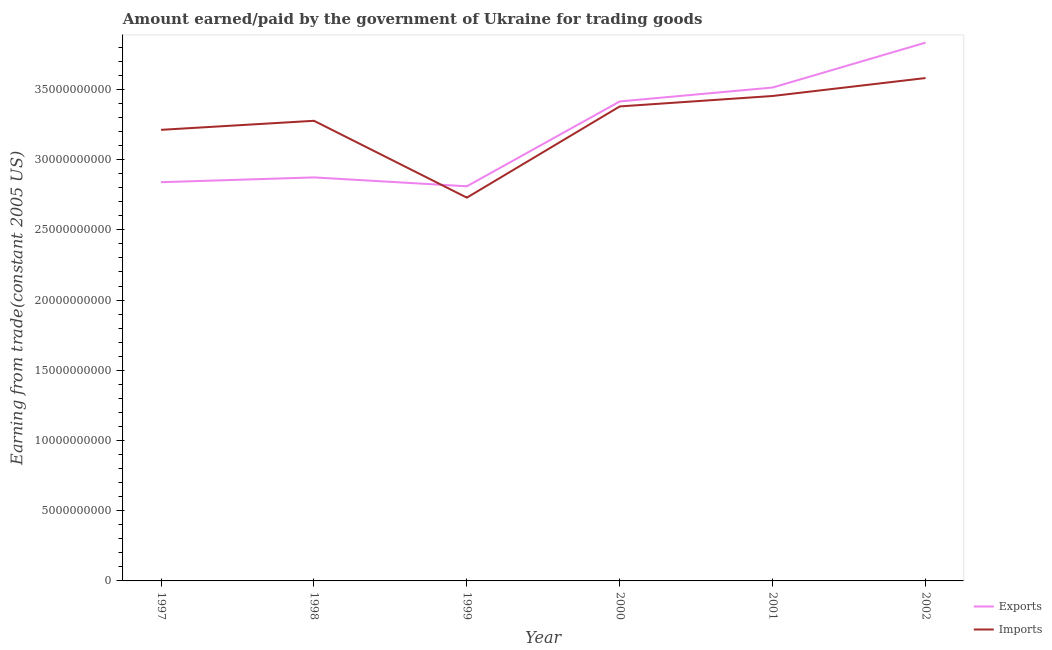How many different coloured lines are there?
Provide a short and direct response. 2. Does the line corresponding to amount paid for imports intersect with the line corresponding to amount earned from exports?
Your answer should be very brief. Yes. Is the number of lines equal to the number of legend labels?
Your answer should be compact. Yes. What is the amount earned from exports in 2001?
Offer a terse response. 3.51e+1. Across all years, what is the maximum amount paid for imports?
Provide a short and direct response. 3.58e+1. Across all years, what is the minimum amount earned from exports?
Your answer should be compact. 2.81e+1. In which year was the amount paid for imports maximum?
Give a very brief answer. 2002. In which year was the amount paid for imports minimum?
Your answer should be very brief. 1999. What is the total amount paid for imports in the graph?
Provide a succinct answer. 1.96e+11. What is the difference between the amount earned from exports in 1998 and that in 2000?
Provide a short and direct response. -5.41e+09. What is the difference between the amount earned from exports in 1999 and the amount paid for imports in 2002?
Your response must be concise. -7.71e+09. What is the average amount paid for imports per year?
Ensure brevity in your answer.  3.27e+1. In the year 1999, what is the difference between the amount earned from exports and amount paid for imports?
Offer a very short reply. 8.09e+08. In how many years, is the amount paid for imports greater than 31000000000 US$?
Keep it short and to the point. 5. What is the ratio of the amount earned from exports in 1998 to that in 2001?
Give a very brief answer. 0.82. Is the amount paid for imports in 2001 less than that in 2002?
Ensure brevity in your answer.  Yes. Is the difference between the amount paid for imports in 1997 and 1999 greater than the difference between the amount earned from exports in 1997 and 1999?
Provide a succinct answer. Yes. What is the difference between the highest and the second highest amount earned from exports?
Offer a terse response. 3.20e+09. What is the difference between the highest and the lowest amount earned from exports?
Keep it short and to the point. 1.02e+1. In how many years, is the amount earned from exports greater than the average amount earned from exports taken over all years?
Provide a succinct answer. 3. Does the amount paid for imports monotonically increase over the years?
Your answer should be compact. No. How many lines are there?
Provide a short and direct response. 2. How many legend labels are there?
Make the answer very short. 2. What is the title of the graph?
Provide a short and direct response. Amount earned/paid by the government of Ukraine for trading goods. What is the label or title of the Y-axis?
Ensure brevity in your answer.  Earning from trade(constant 2005 US). What is the Earning from trade(constant 2005 US) of Exports in 1997?
Offer a very short reply. 2.84e+1. What is the Earning from trade(constant 2005 US) of Imports in 1997?
Your answer should be compact. 3.21e+1. What is the Earning from trade(constant 2005 US) of Exports in 1998?
Give a very brief answer. 2.87e+1. What is the Earning from trade(constant 2005 US) in Imports in 1998?
Make the answer very short. 3.28e+1. What is the Earning from trade(constant 2005 US) in Exports in 1999?
Offer a very short reply. 2.81e+1. What is the Earning from trade(constant 2005 US) in Imports in 1999?
Keep it short and to the point. 2.73e+1. What is the Earning from trade(constant 2005 US) of Exports in 2000?
Offer a very short reply. 3.41e+1. What is the Earning from trade(constant 2005 US) of Imports in 2000?
Your answer should be very brief. 3.38e+1. What is the Earning from trade(constant 2005 US) in Exports in 2001?
Ensure brevity in your answer.  3.51e+1. What is the Earning from trade(constant 2005 US) in Imports in 2001?
Give a very brief answer. 3.45e+1. What is the Earning from trade(constant 2005 US) in Exports in 2002?
Provide a succinct answer. 3.83e+1. What is the Earning from trade(constant 2005 US) in Imports in 2002?
Offer a terse response. 3.58e+1. Across all years, what is the maximum Earning from trade(constant 2005 US) of Exports?
Make the answer very short. 3.83e+1. Across all years, what is the maximum Earning from trade(constant 2005 US) in Imports?
Provide a short and direct response. 3.58e+1. Across all years, what is the minimum Earning from trade(constant 2005 US) in Exports?
Ensure brevity in your answer.  2.81e+1. Across all years, what is the minimum Earning from trade(constant 2005 US) of Imports?
Your response must be concise. 2.73e+1. What is the total Earning from trade(constant 2005 US) of Exports in the graph?
Offer a very short reply. 1.93e+11. What is the total Earning from trade(constant 2005 US) in Imports in the graph?
Keep it short and to the point. 1.96e+11. What is the difference between the Earning from trade(constant 2005 US) in Exports in 1997 and that in 1998?
Ensure brevity in your answer.  -3.41e+08. What is the difference between the Earning from trade(constant 2005 US) in Imports in 1997 and that in 1998?
Your answer should be compact. -6.42e+08. What is the difference between the Earning from trade(constant 2005 US) of Exports in 1997 and that in 1999?
Give a very brief answer. 2.91e+08. What is the difference between the Earning from trade(constant 2005 US) of Imports in 1997 and that in 1999?
Your answer should be compact. 4.83e+09. What is the difference between the Earning from trade(constant 2005 US) of Exports in 1997 and that in 2000?
Ensure brevity in your answer.  -5.75e+09. What is the difference between the Earning from trade(constant 2005 US) of Imports in 1997 and that in 2000?
Offer a terse response. -1.67e+09. What is the difference between the Earning from trade(constant 2005 US) of Exports in 1997 and that in 2001?
Your answer should be very brief. -6.74e+09. What is the difference between the Earning from trade(constant 2005 US) of Imports in 1997 and that in 2001?
Provide a succinct answer. -2.41e+09. What is the difference between the Earning from trade(constant 2005 US) of Exports in 1997 and that in 2002?
Ensure brevity in your answer.  -9.94e+09. What is the difference between the Earning from trade(constant 2005 US) of Imports in 1997 and that in 2002?
Your answer should be compact. -3.69e+09. What is the difference between the Earning from trade(constant 2005 US) of Exports in 1998 and that in 1999?
Offer a terse response. 6.32e+08. What is the difference between the Earning from trade(constant 2005 US) of Imports in 1998 and that in 1999?
Keep it short and to the point. 5.47e+09. What is the difference between the Earning from trade(constant 2005 US) of Exports in 1998 and that in 2000?
Provide a short and direct response. -5.41e+09. What is the difference between the Earning from trade(constant 2005 US) in Imports in 1998 and that in 2000?
Your response must be concise. -1.02e+09. What is the difference between the Earning from trade(constant 2005 US) in Exports in 1998 and that in 2001?
Your answer should be very brief. -6.40e+09. What is the difference between the Earning from trade(constant 2005 US) in Imports in 1998 and that in 2001?
Your answer should be compact. -1.77e+09. What is the difference between the Earning from trade(constant 2005 US) in Exports in 1998 and that in 2002?
Give a very brief answer. -9.60e+09. What is the difference between the Earning from trade(constant 2005 US) in Imports in 1998 and that in 2002?
Keep it short and to the point. -3.05e+09. What is the difference between the Earning from trade(constant 2005 US) of Exports in 1999 and that in 2000?
Make the answer very short. -6.04e+09. What is the difference between the Earning from trade(constant 2005 US) of Imports in 1999 and that in 2000?
Offer a very short reply. -6.50e+09. What is the difference between the Earning from trade(constant 2005 US) of Exports in 1999 and that in 2001?
Keep it short and to the point. -7.03e+09. What is the difference between the Earning from trade(constant 2005 US) in Imports in 1999 and that in 2001?
Your answer should be very brief. -7.24e+09. What is the difference between the Earning from trade(constant 2005 US) in Exports in 1999 and that in 2002?
Make the answer very short. -1.02e+1. What is the difference between the Earning from trade(constant 2005 US) in Imports in 1999 and that in 2002?
Keep it short and to the point. -8.52e+09. What is the difference between the Earning from trade(constant 2005 US) in Exports in 2000 and that in 2001?
Your answer should be very brief. -9.90e+08. What is the difference between the Earning from trade(constant 2005 US) in Imports in 2000 and that in 2001?
Offer a very short reply. -7.43e+08. What is the difference between the Earning from trade(constant 2005 US) in Exports in 2000 and that in 2002?
Provide a short and direct response. -4.19e+09. What is the difference between the Earning from trade(constant 2005 US) in Imports in 2000 and that in 2002?
Your response must be concise. -2.02e+09. What is the difference between the Earning from trade(constant 2005 US) in Exports in 2001 and that in 2002?
Offer a terse response. -3.20e+09. What is the difference between the Earning from trade(constant 2005 US) of Imports in 2001 and that in 2002?
Your answer should be very brief. -1.28e+09. What is the difference between the Earning from trade(constant 2005 US) of Exports in 1997 and the Earning from trade(constant 2005 US) of Imports in 1998?
Ensure brevity in your answer.  -4.37e+09. What is the difference between the Earning from trade(constant 2005 US) in Exports in 1997 and the Earning from trade(constant 2005 US) in Imports in 1999?
Keep it short and to the point. 1.10e+09. What is the difference between the Earning from trade(constant 2005 US) of Exports in 1997 and the Earning from trade(constant 2005 US) of Imports in 2000?
Keep it short and to the point. -5.40e+09. What is the difference between the Earning from trade(constant 2005 US) of Exports in 1997 and the Earning from trade(constant 2005 US) of Imports in 2001?
Your answer should be very brief. -6.14e+09. What is the difference between the Earning from trade(constant 2005 US) in Exports in 1997 and the Earning from trade(constant 2005 US) in Imports in 2002?
Give a very brief answer. -7.42e+09. What is the difference between the Earning from trade(constant 2005 US) of Exports in 1998 and the Earning from trade(constant 2005 US) of Imports in 1999?
Give a very brief answer. 1.44e+09. What is the difference between the Earning from trade(constant 2005 US) of Exports in 1998 and the Earning from trade(constant 2005 US) of Imports in 2000?
Your answer should be compact. -5.05e+09. What is the difference between the Earning from trade(constant 2005 US) of Exports in 1998 and the Earning from trade(constant 2005 US) of Imports in 2001?
Provide a short and direct response. -5.80e+09. What is the difference between the Earning from trade(constant 2005 US) of Exports in 1998 and the Earning from trade(constant 2005 US) of Imports in 2002?
Ensure brevity in your answer.  -7.08e+09. What is the difference between the Earning from trade(constant 2005 US) of Exports in 1999 and the Earning from trade(constant 2005 US) of Imports in 2000?
Your answer should be very brief. -5.69e+09. What is the difference between the Earning from trade(constant 2005 US) of Exports in 1999 and the Earning from trade(constant 2005 US) of Imports in 2001?
Ensure brevity in your answer.  -6.43e+09. What is the difference between the Earning from trade(constant 2005 US) in Exports in 1999 and the Earning from trade(constant 2005 US) in Imports in 2002?
Keep it short and to the point. -7.71e+09. What is the difference between the Earning from trade(constant 2005 US) in Exports in 2000 and the Earning from trade(constant 2005 US) in Imports in 2001?
Your response must be concise. -3.88e+08. What is the difference between the Earning from trade(constant 2005 US) in Exports in 2000 and the Earning from trade(constant 2005 US) in Imports in 2002?
Give a very brief answer. -1.67e+09. What is the difference between the Earning from trade(constant 2005 US) in Exports in 2001 and the Earning from trade(constant 2005 US) in Imports in 2002?
Your answer should be very brief. -6.76e+08. What is the average Earning from trade(constant 2005 US) of Exports per year?
Provide a short and direct response. 3.21e+1. What is the average Earning from trade(constant 2005 US) of Imports per year?
Your answer should be very brief. 3.27e+1. In the year 1997, what is the difference between the Earning from trade(constant 2005 US) in Exports and Earning from trade(constant 2005 US) in Imports?
Ensure brevity in your answer.  -3.73e+09. In the year 1998, what is the difference between the Earning from trade(constant 2005 US) of Exports and Earning from trade(constant 2005 US) of Imports?
Give a very brief answer. -4.03e+09. In the year 1999, what is the difference between the Earning from trade(constant 2005 US) in Exports and Earning from trade(constant 2005 US) in Imports?
Your answer should be compact. 8.09e+08. In the year 2000, what is the difference between the Earning from trade(constant 2005 US) in Exports and Earning from trade(constant 2005 US) in Imports?
Ensure brevity in your answer.  3.55e+08. In the year 2001, what is the difference between the Earning from trade(constant 2005 US) in Exports and Earning from trade(constant 2005 US) in Imports?
Provide a succinct answer. 6.02e+08. In the year 2002, what is the difference between the Earning from trade(constant 2005 US) of Exports and Earning from trade(constant 2005 US) of Imports?
Your response must be concise. 2.52e+09. What is the ratio of the Earning from trade(constant 2005 US) of Imports in 1997 to that in 1998?
Your answer should be very brief. 0.98. What is the ratio of the Earning from trade(constant 2005 US) in Exports in 1997 to that in 1999?
Give a very brief answer. 1.01. What is the ratio of the Earning from trade(constant 2005 US) of Imports in 1997 to that in 1999?
Offer a very short reply. 1.18. What is the ratio of the Earning from trade(constant 2005 US) of Exports in 1997 to that in 2000?
Provide a short and direct response. 0.83. What is the ratio of the Earning from trade(constant 2005 US) in Imports in 1997 to that in 2000?
Offer a terse response. 0.95. What is the ratio of the Earning from trade(constant 2005 US) in Exports in 1997 to that in 2001?
Give a very brief answer. 0.81. What is the ratio of the Earning from trade(constant 2005 US) in Imports in 1997 to that in 2001?
Your response must be concise. 0.93. What is the ratio of the Earning from trade(constant 2005 US) in Exports in 1997 to that in 2002?
Your answer should be very brief. 0.74. What is the ratio of the Earning from trade(constant 2005 US) in Imports in 1997 to that in 2002?
Offer a terse response. 0.9. What is the ratio of the Earning from trade(constant 2005 US) of Exports in 1998 to that in 1999?
Your answer should be very brief. 1.02. What is the ratio of the Earning from trade(constant 2005 US) in Imports in 1998 to that in 1999?
Make the answer very short. 1.2. What is the ratio of the Earning from trade(constant 2005 US) in Exports in 1998 to that in 2000?
Offer a terse response. 0.84. What is the ratio of the Earning from trade(constant 2005 US) in Imports in 1998 to that in 2000?
Make the answer very short. 0.97. What is the ratio of the Earning from trade(constant 2005 US) in Exports in 1998 to that in 2001?
Your response must be concise. 0.82. What is the ratio of the Earning from trade(constant 2005 US) in Imports in 1998 to that in 2001?
Provide a succinct answer. 0.95. What is the ratio of the Earning from trade(constant 2005 US) in Exports in 1998 to that in 2002?
Your answer should be compact. 0.75. What is the ratio of the Earning from trade(constant 2005 US) of Imports in 1998 to that in 2002?
Keep it short and to the point. 0.92. What is the ratio of the Earning from trade(constant 2005 US) in Exports in 1999 to that in 2000?
Make the answer very short. 0.82. What is the ratio of the Earning from trade(constant 2005 US) of Imports in 1999 to that in 2000?
Your answer should be very brief. 0.81. What is the ratio of the Earning from trade(constant 2005 US) in Exports in 1999 to that in 2001?
Offer a terse response. 0.8. What is the ratio of the Earning from trade(constant 2005 US) of Imports in 1999 to that in 2001?
Keep it short and to the point. 0.79. What is the ratio of the Earning from trade(constant 2005 US) in Exports in 1999 to that in 2002?
Provide a short and direct response. 0.73. What is the ratio of the Earning from trade(constant 2005 US) of Imports in 1999 to that in 2002?
Your response must be concise. 0.76. What is the ratio of the Earning from trade(constant 2005 US) of Exports in 2000 to that in 2001?
Keep it short and to the point. 0.97. What is the ratio of the Earning from trade(constant 2005 US) in Imports in 2000 to that in 2001?
Keep it short and to the point. 0.98. What is the ratio of the Earning from trade(constant 2005 US) of Exports in 2000 to that in 2002?
Your answer should be compact. 0.89. What is the ratio of the Earning from trade(constant 2005 US) in Imports in 2000 to that in 2002?
Make the answer very short. 0.94. What is the ratio of the Earning from trade(constant 2005 US) of Exports in 2001 to that in 2002?
Provide a short and direct response. 0.92. What is the ratio of the Earning from trade(constant 2005 US) in Imports in 2001 to that in 2002?
Your answer should be compact. 0.96. What is the difference between the highest and the second highest Earning from trade(constant 2005 US) in Exports?
Your answer should be very brief. 3.20e+09. What is the difference between the highest and the second highest Earning from trade(constant 2005 US) of Imports?
Provide a short and direct response. 1.28e+09. What is the difference between the highest and the lowest Earning from trade(constant 2005 US) of Exports?
Offer a very short reply. 1.02e+1. What is the difference between the highest and the lowest Earning from trade(constant 2005 US) of Imports?
Your answer should be compact. 8.52e+09. 